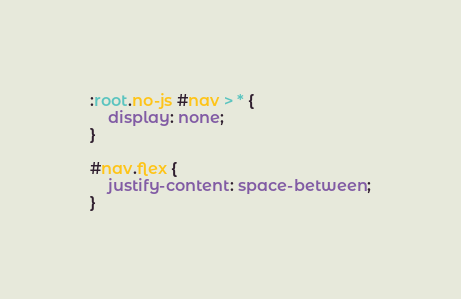Convert code to text. <code><loc_0><loc_0><loc_500><loc_500><_CSS_>:root.no-js #nav > * {
	display: none;
}

#nav.flex {
	justify-content: space-between;
}
</code> 